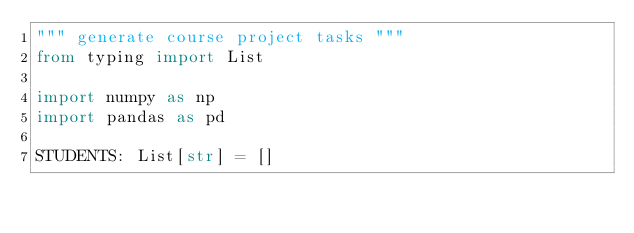Convert code to text. <code><loc_0><loc_0><loc_500><loc_500><_Python_>""" generate course project tasks """
from typing import List

import numpy as np
import pandas as pd

STUDENTS: List[str] = []</code> 